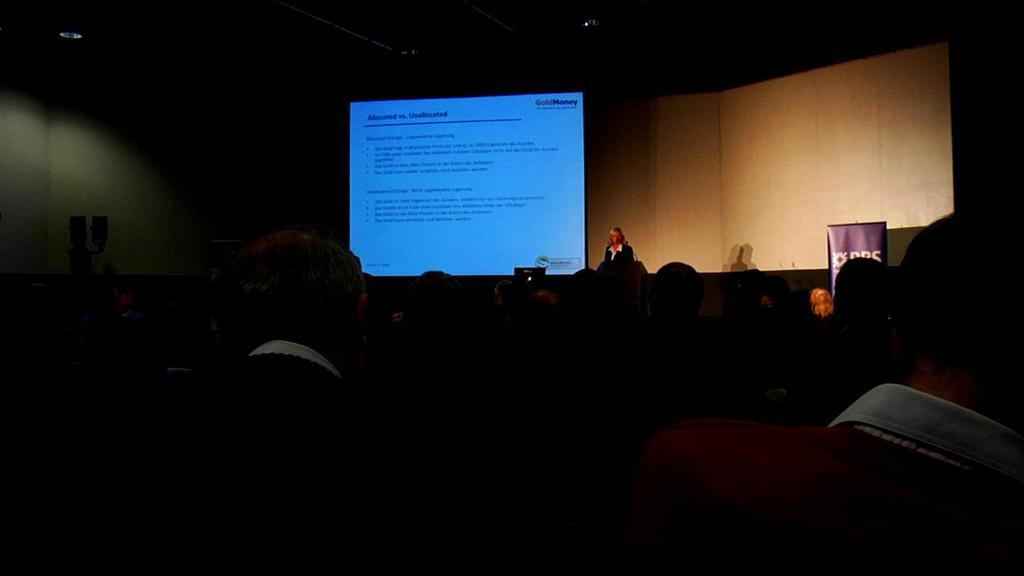How many persons are in the image? There are persons in the image. Can you describe the person on the stage? There is a person on a stage in the image. What is located beside the person on the stage? There is a screen beside the person on the stage. What type of structure can be seen in the image? There is a wall in the image. How would you describe the overall color scheme of the image? The background of the image is dark in color. What type of cord is being used to power the metal pump in the image? There is no cord or metal pump present in the image. 